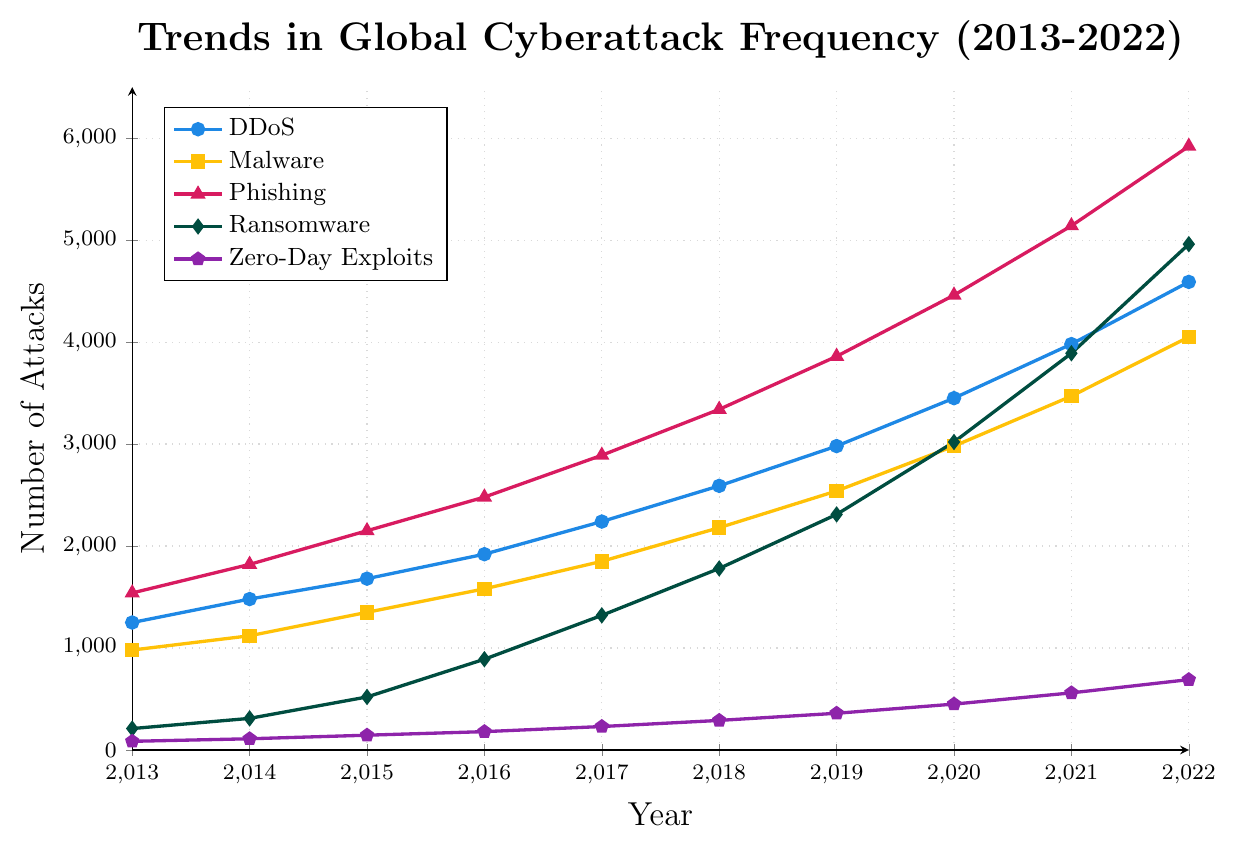What was the total number of DDoS attacks in 2013 and 2022? Add the number of DDoS attacks in 2013 (1250) and 2022 (4590) to get the total: 1250 + 4590
Answer: 5840 Which type of attack had the highest increase in frequency from 2013 to 2022? Calculate the increase by finding the difference between the frequencies in 2022 and 2013 for each attack type. DDoS: 4590-1250=3340, Malware: 4050-980=3070, Phishing: 5920-1540=4380, Ransomware: 4960-210=4750, Zero-Day Exploits: 690-85=605. Ransomware had the highest increase: 4750.
Answer: Ransomware Which attack type had more attacks in 2018: Phishing or Malware? Compare the values of Phishing (3340) and Malware (2180) in 2018 to see which is higher. Phishing had more attacks: 3340.
Answer: Phishing What was the average number of Zero-Day Exploits attacks from 2013 to 2022? Sum the values of Zero-Day Exploits from 2013 to 2022: 85+110+145+180+230+290+360+450+560+690, and divide by the number of years (10): 3100 / 10
Answer: 310 By how much did the number of Ransomware attacks increase from 2015 to 2018? Subtract the number of Ransomware attacks in 2015 (520) from the number in 2018 (1780). 1780 - 520 = 1260
Answer: 1260 In which year did Phishing attacks first exceed 4000? Identify the first year in the dataset where the number of Phishing attacks is greater than 4000. In 2019, Phishing attacks were 3860, and in 2020, they were 4460. So, the first year is 2020.
Answer: 2020 Which type of attack had the smallest increase in frequency from 2013 to 2022? Calculate the increase for each attack type and find the smallest: DDoS: 3340, Malware: 3070, Phishing: 4380, Ransomware: 4750, Zero-Day Exploits: 605. Zero-Day Exploits had the smallest increase: 605.
Answer: Zero-Day Exploits What is the difference in the number of Phishing and Malware attacks in 2022? Subtract the number of Malware attacks (4050) from the number of Phishing attacks (5920) in 2022. 5920 - 4050 = 1870
Answer: 1870 In which year did the number of DDoS attacks first exceed 3000? Identify the first year in the dataset where the number of DDoS attacks is greater than 3000. In 2018, DDoS attacks were 2590, and in 2019, they were 2980. In 2020, they were 3450, so the first year is 2020.
Answer: 2020 